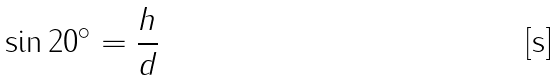Convert formula to latex. <formula><loc_0><loc_0><loc_500><loc_500>\sin 2 0 ^ { \circ } = \frac { h } { d }</formula> 